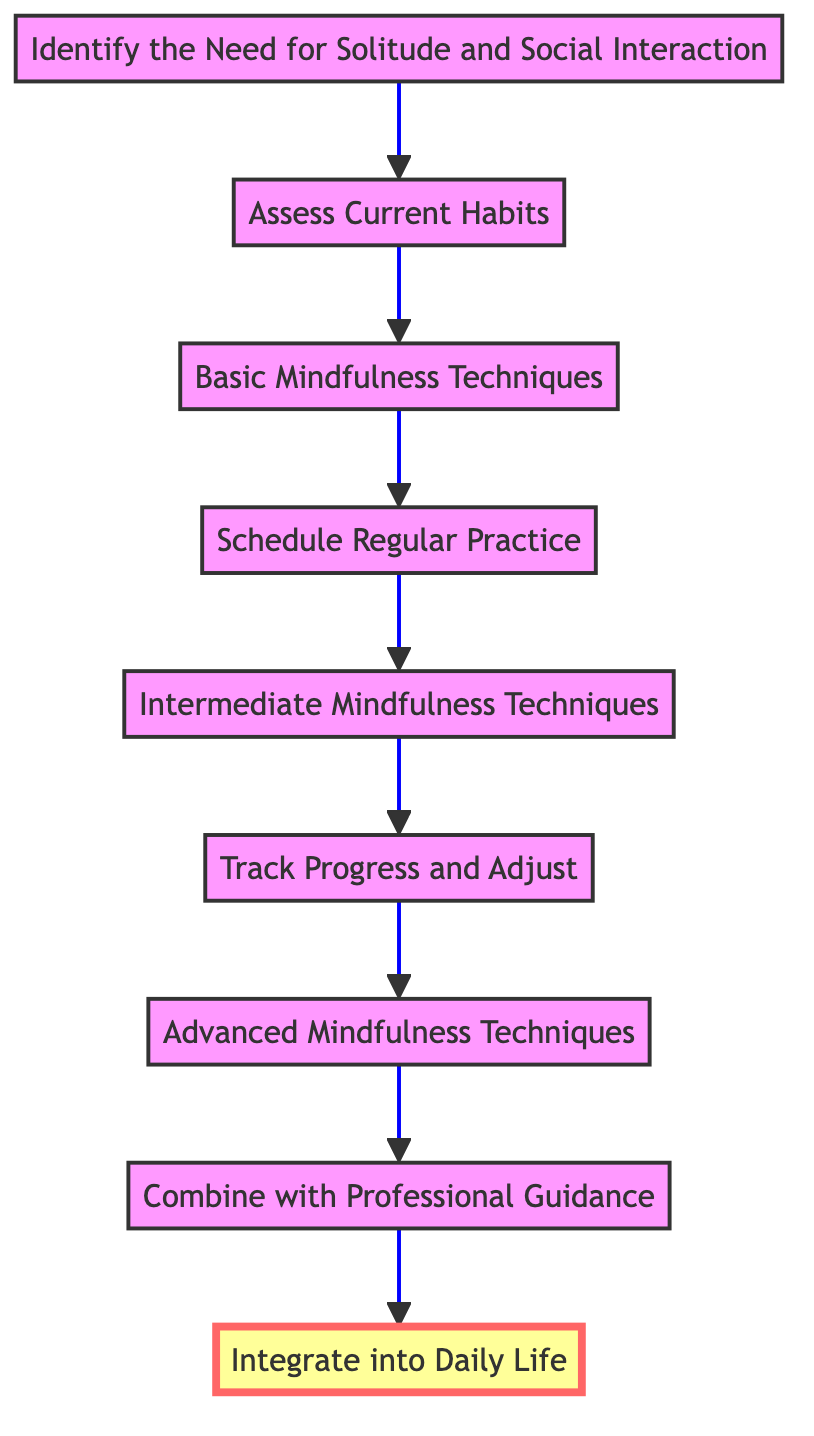What is the first step in the mindfulness routine? The first step in the mindfulness routine, according to the diagram, is "Identify the Need for Solitude and Social Interaction." This can be found at the bottom of the flow chart, indicating it is the starting point.
Answer: Identify the Need for Solitude and Social Interaction How many nodes are in the diagram? By counting each of the unique steps represented in the flowchart, we find there are a total of nine nodes. Each node corresponds to a specific step in developing a mindfulness routine.
Answer: 9 What follows after "Track Progress and Adjust"? After "Track Progress and Adjust," the next step is "Advanced Mindfulness Techniques." This relationship is indicated by the arrow connecting these two nodes in the upward flow of the chart.
Answer: Advanced Mindfulness Techniques What is the last step in the mindfulness routine? The last step depicted in the flowchart is "Integrate into Daily Life," which is at the top of the diagram, indicating it is the final outcome of the process.
Answer: Integrate into Daily Life Which step involves seeking advice from professionals? The step that involves seeking advice from professionals is "Combine with Professional Guidance." This node specifically indicates the action of consulting mental health professionals or mindfulness coaches.
Answer: Combine with Professional Guidance How many intermediate steps are there from basic to advanced techniques? To find the number of intermediate steps, we count the nodes between "Basic Mindfulness Techniques" and "Advanced Mindfulness Techniques," which are "Schedule Regular Practice," "Intermediate Mindfulness Techniques," and "Track Progress and Adjust," totaling three intermediate steps.
Answer: 3 What is the direct connection between "Basic Mindfulness Techniques" and "Intermediate Mindfulness Techniques"? The direct connection is represented by an arrow that flows from "Basic Mindfulness Techniques" to "Intermediate Mindfulness Techniques," indicating that the latter directly follows the former in the sequence of developing mindfulness practices.
Answer: Intermediate Mindfulness Techniques What is the purpose of "Assess Current Habits"? The purpose of "Assess Current Habits" is to evaluate daily routines and their impact on mental health and focus. It serves as a crucial assessment step before moving forward in the mindfulness routine.
Answer: Evaluate daily routines and their impact on mental health and focus 